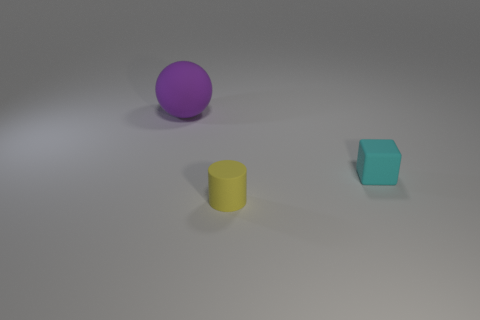Add 3 large things. How many objects exist? 6 Subtract all cubes. How many objects are left? 2 Add 3 large objects. How many large objects are left? 4 Add 2 small brown metallic objects. How many small brown metallic objects exist? 2 Subtract 0 blue cylinders. How many objects are left? 3 Subtract all tiny purple things. Subtract all small yellow things. How many objects are left? 2 